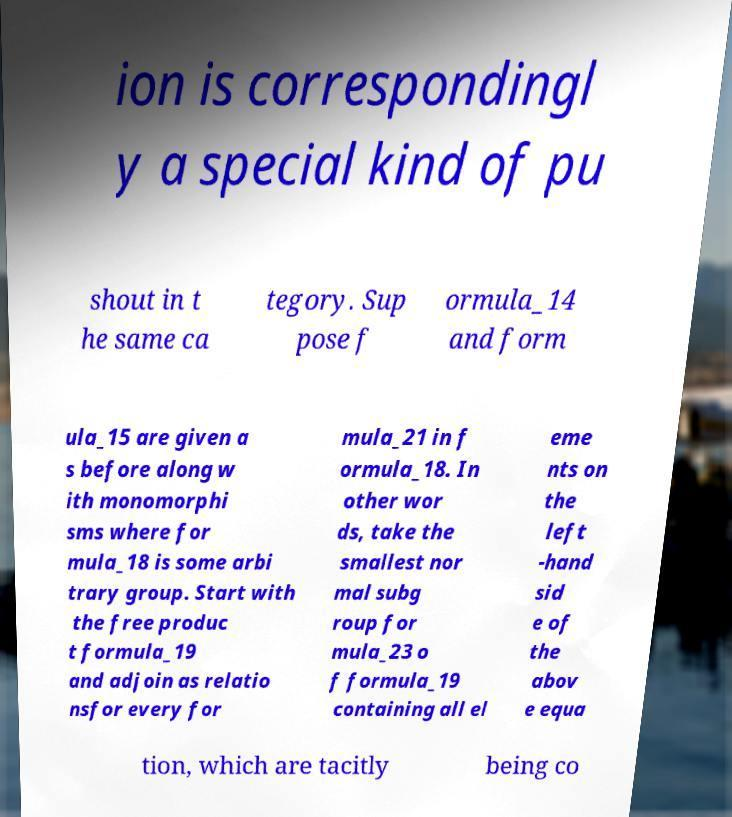What messages or text are displayed in this image? I need them in a readable, typed format. ion is correspondingl y a special kind of pu shout in t he same ca tegory. Sup pose f ormula_14 and form ula_15 are given a s before along w ith monomorphi sms where for mula_18 is some arbi trary group. Start with the free produc t formula_19 and adjoin as relatio nsfor every for mula_21 in f ormula_18. In other wor ds, take the smallest nor mal subg roup for mula_23 o f formula_19 containing all el eme nts on the left -hand sid e of the abov e equa tion, which are tacitly being co 